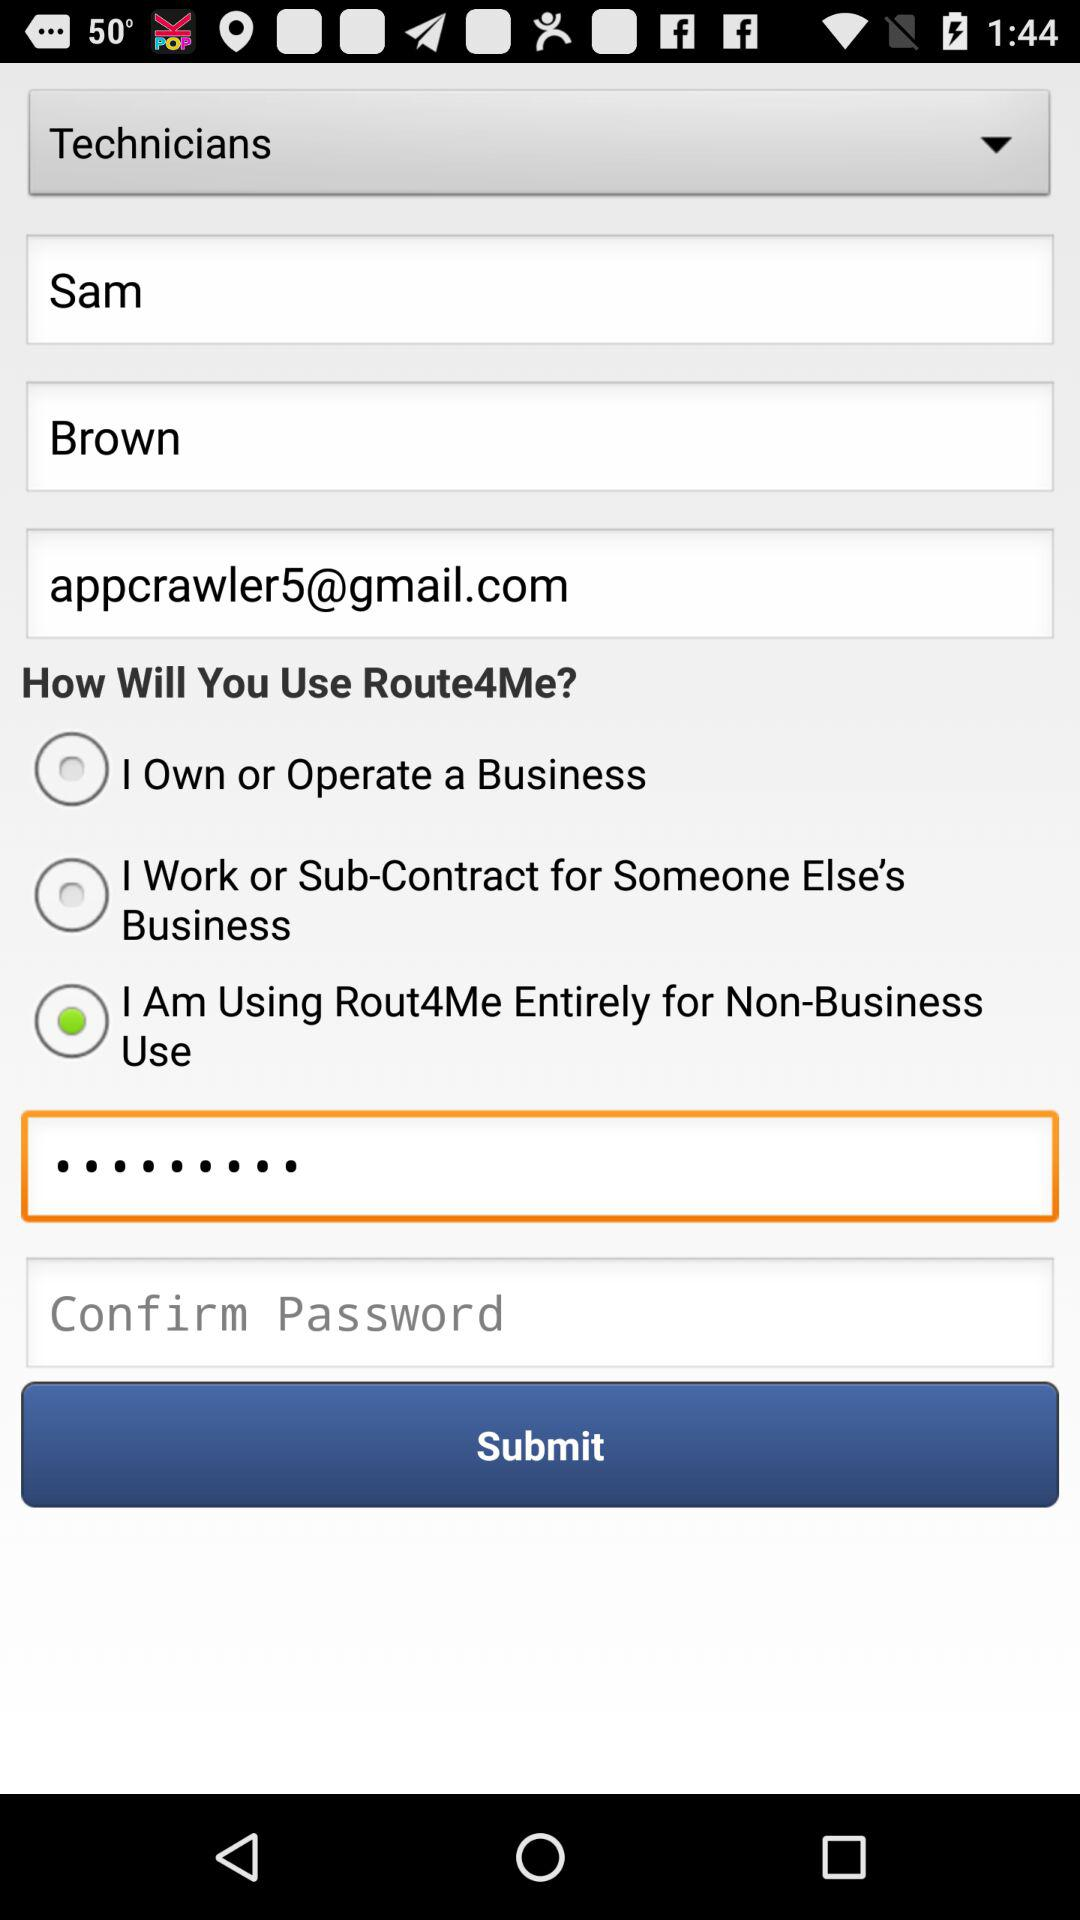What is the email address? The email address is appcrawler5@gmail.com. 